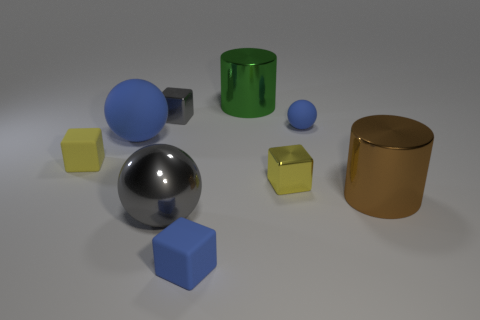Is the big metallic ball the same color as the large rubber thing?
Make the answer very short. No. There is a yellow metallic thing that is the same shape as the tiny gray metal thing; what is its size?
Give a very brief answer. Small. What number of cyan cylinders are the same material as the big blue ball?
Offer a terse response. 0. Is the material of the small yellow object left of the large matte sphere the same as the tiny gray thing?
Offer a very short reply. No. Are there an equal number of matte objects in front of the large metal ball and small blue rubber blocks?
Your answer should be compact. Yes. What is the size of the gray metal cube?
Provide a short and direct response. Small. There is a block that is the same color as the large rubber object; what is it made of?
Your response must be concise. Rubber. How many tiny spheres are the same color as the big rubber object?
Your answer should be compact. 1. Do the yellow shiny object and the gray block have the same size?
Offer a terse response. Yes. There is a yellow rubber thing that is to the left of the big green cylinder on the left side of the large brown metallic object; how big is it?
Keep it short and to the point. Small. 